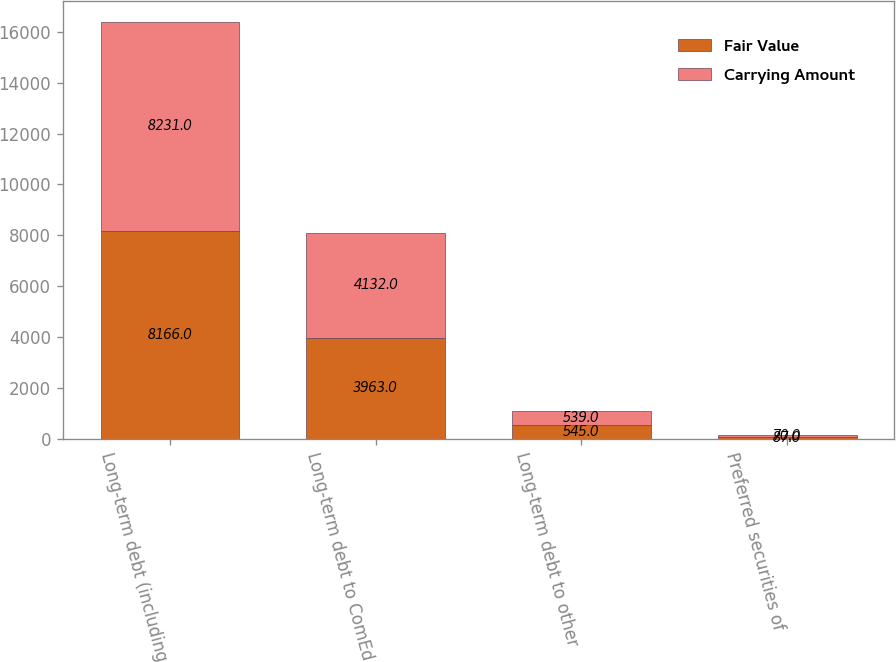Convert chart. <chart><loc_0><loc_0><loc_500><loc_500><stacked_bar_chart><ecel><fcel>Long-term debt (including<fcel>Long-term debt to ComEd<fcel>Long-term debt to other<fcel>Preferred securities of<nl><fcel>Fair Value<fcel>8166<fcel>3963<fcel>545<fcel>87<nl><fcel>Carrying Amount<fcel>8231<fcel>4132<fcel>539<fcel>70<nl></chart> 